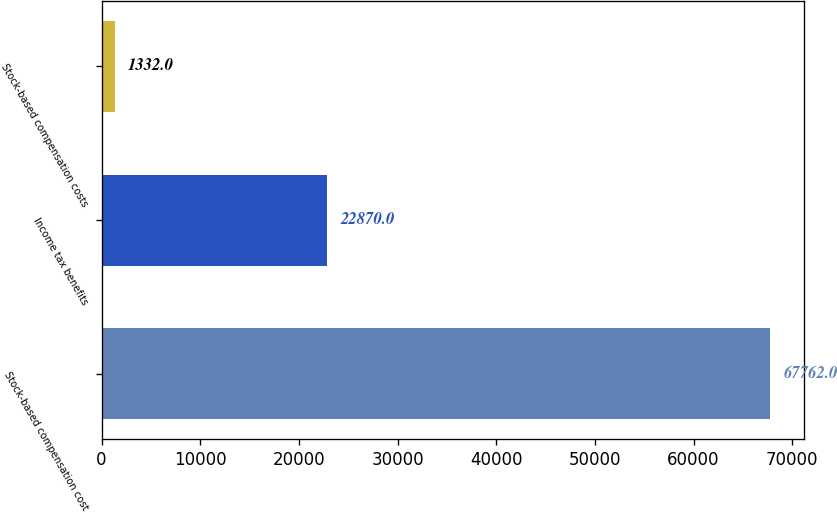Convert chart to OTSL. <chart><loc_0><loc_0><loc_500><loc_500><bar_chart><fcel>Stock-based compensation cost<fcel>Income tax benefits<fcel>Stock-based compensation costs<nl><fcel>67762<fcel>22870<fcel>1332<nl></chart> 